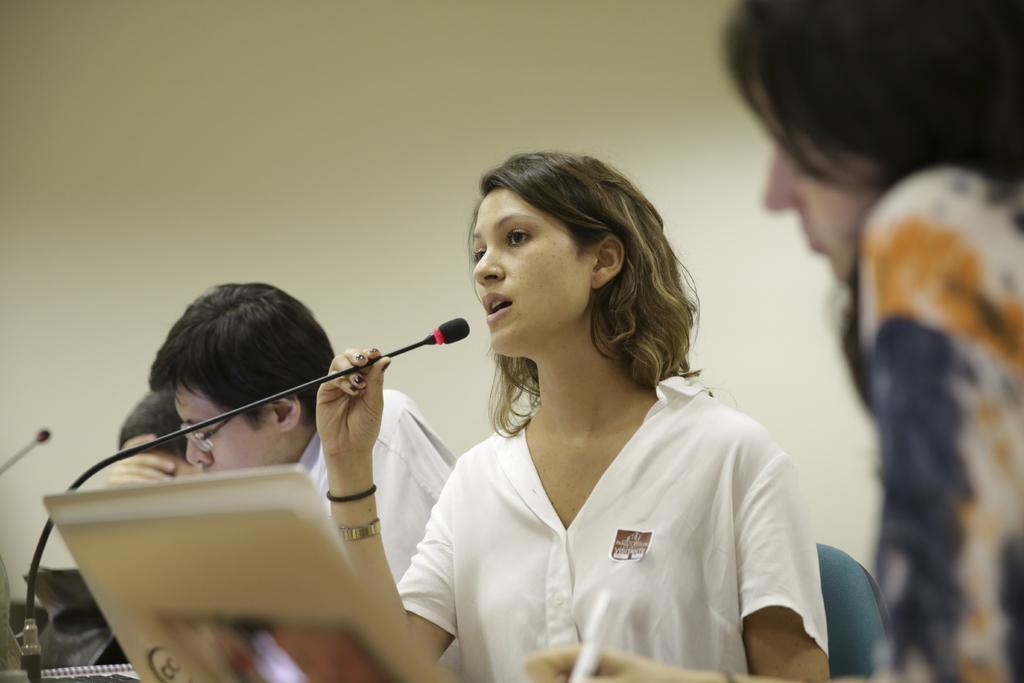Can you describe this image briefly? In this image I see a woman who is wearing white shirt and I see that she is holding a mic and I see a man over here and I see a thing over here. I see that this woman is sitting on a chair and I see a person over here who is holding a pen and I see another mac over here. In the background I see the wall. 